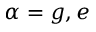Convert formula to latex. <formula><loc_0><loc_0><loc_500><loc_500>\alpha = g , e</formula> 